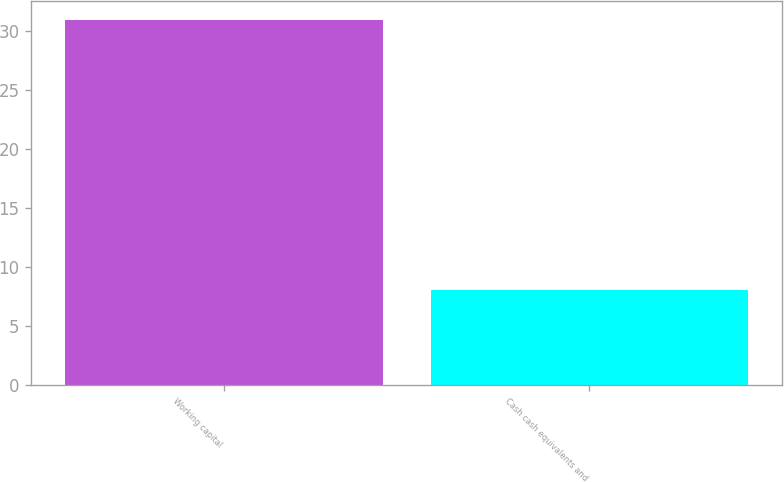Convert chart to OTSL. <chart><loc_0><loc_0><loc_500><loc_500><bar_chart><fcel>Working capital<fcel>Cash cash equivalents and<nl><fcel>31<fcel>8<nl></chart> 